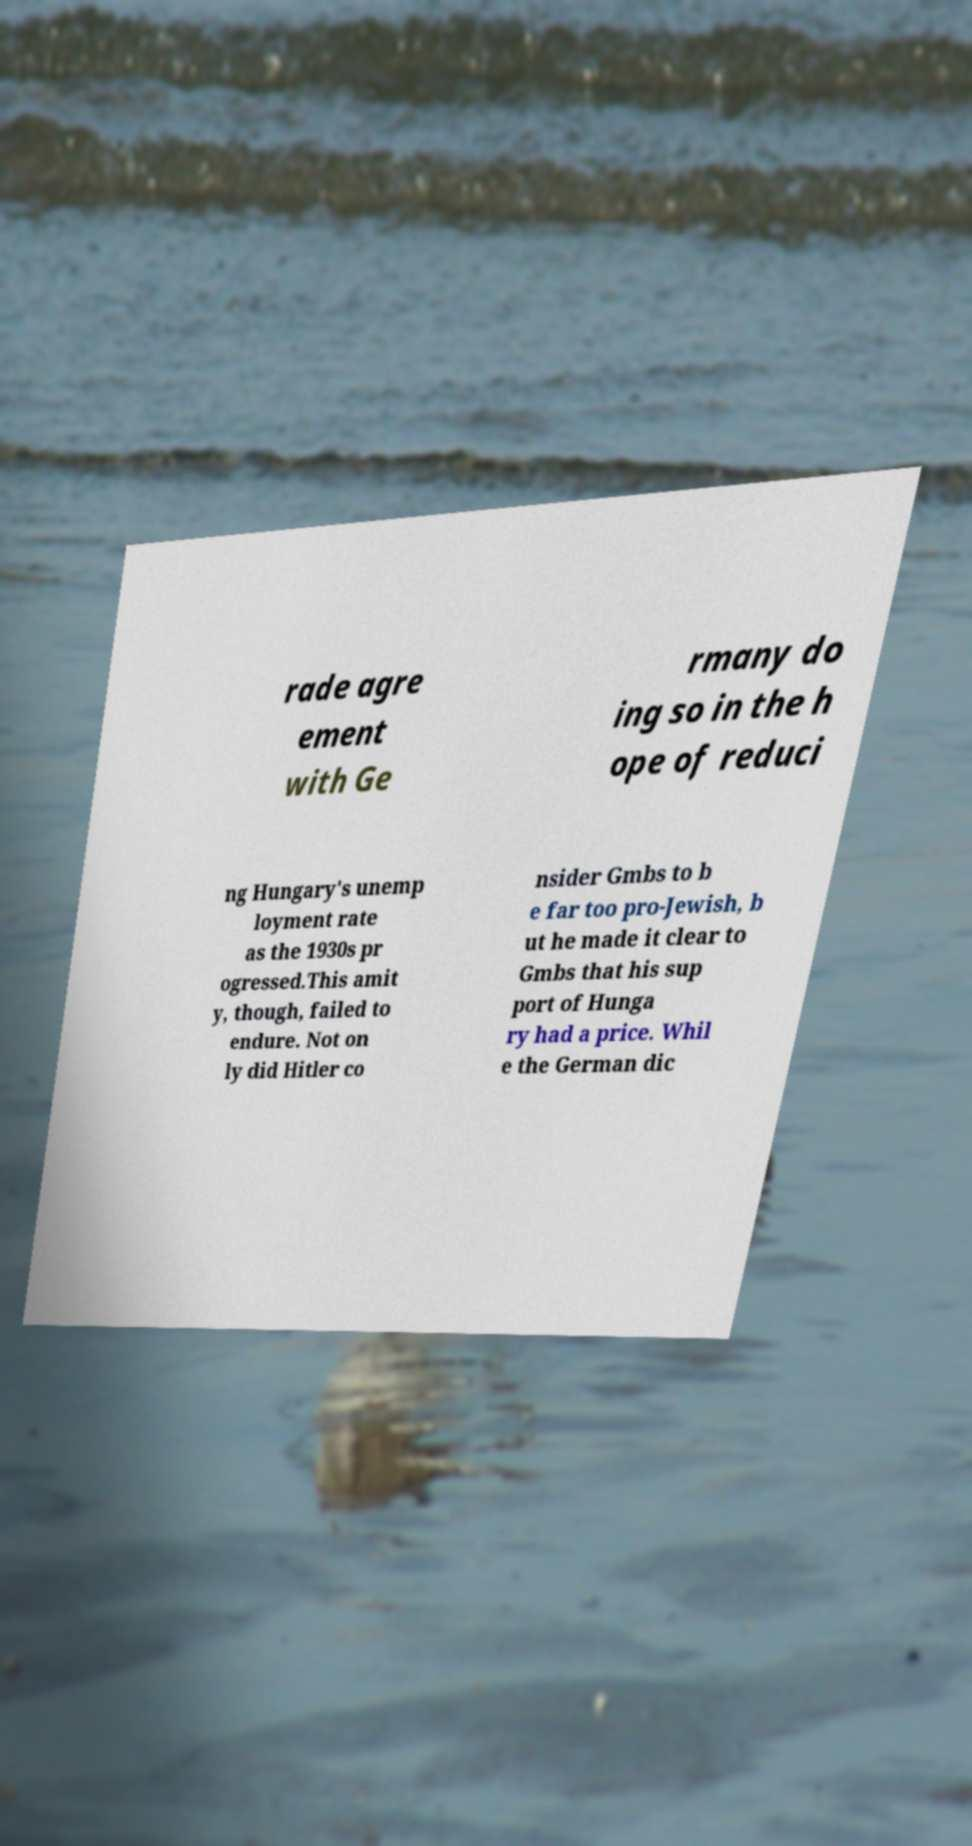Can you read and provide the text displayed in the image?This photo seems to have some interesting text. Can you extract and type it out for me? rade agre ement with Ge rmany do ing so in the h ope of reduci ng Hungary's unemp loyment rate as the 1930s pr ogressed.This amit y, though, failed to endure. Not on ly did Hitler co nsider Gmbs to b e far too pro-Jewish, b ut he made it clear to Gmbs that his sup port of Hunga ry had a price. Whil e the German dic 